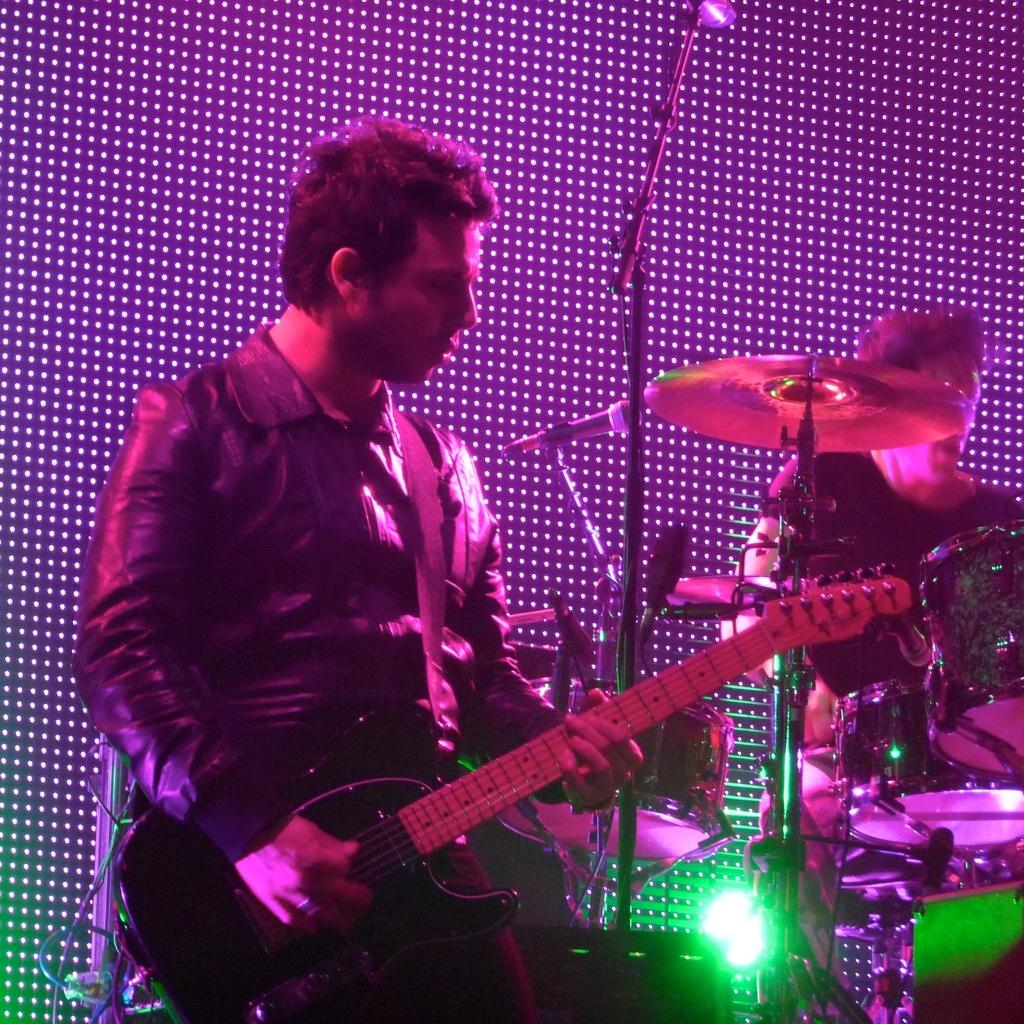What is the main activity of the person in the image? The person in the image is playing a musical instrument. Can you describe the setting of the image? There is another person and musical instruments in the background of the image, along with lights and other objects. How many people are visible in the image? There are two people visible in the image. What type of cloud can be seen in the image? There are no clouds visible in the image. How many dimes are scattered on the floor in the image? There are no dimes present in the image. 